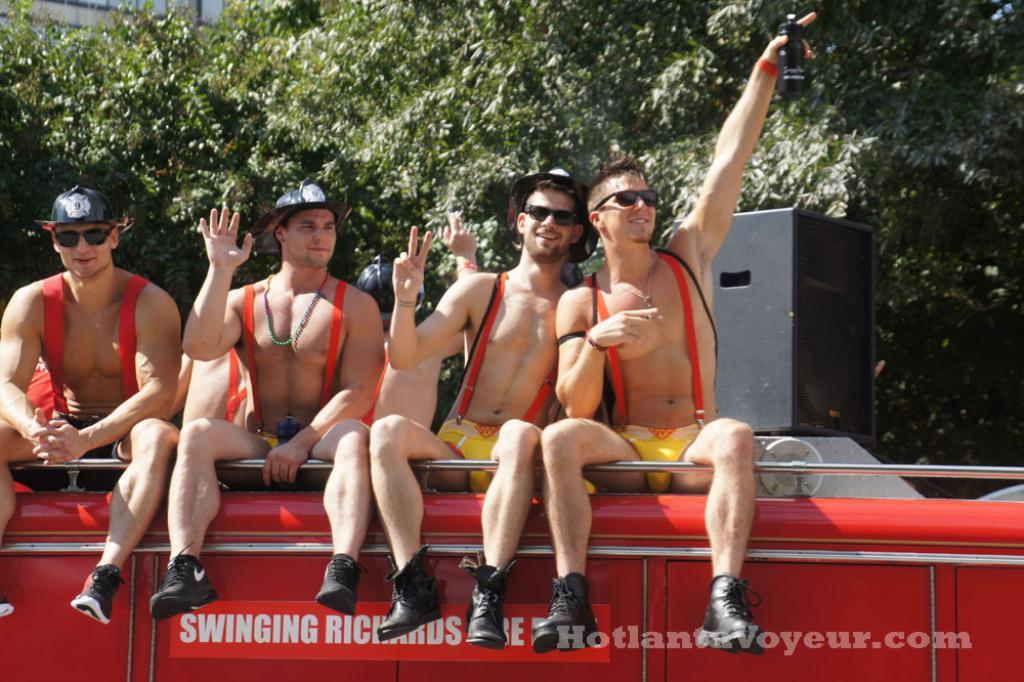How many people are on the vehicle in the image? There are four persons sitting on the vehicle. What can be seen on the vehicle besides the people? There is text on the vehicle. What is visible in the background of the image? There are trees and a box in the background of the image. Where is the additional text located in the image? There is text in the bottom right corner of the image. What type of alley can be seen in the image? There is no alley present in the image. How many marks are visible on the vehicle? There is no mention of marks on the vehicle in the provided facts. 